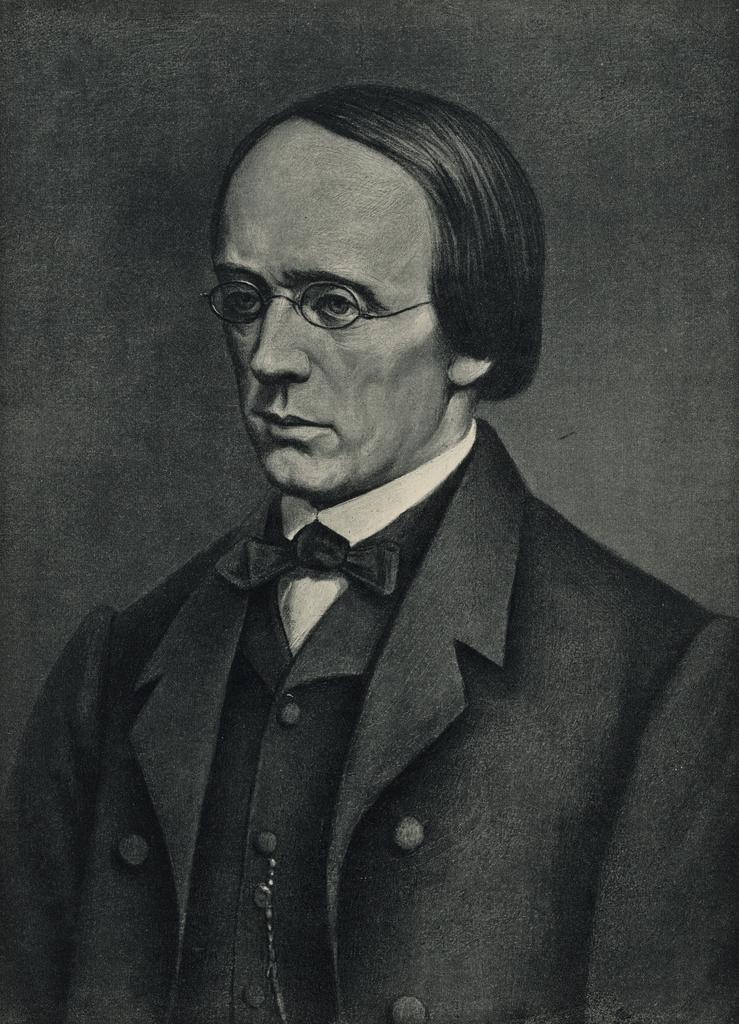Can you describe this image briefly? This image is a painting. In this painting we can see a man. He is wearing glasses. In the background there is a wall. 